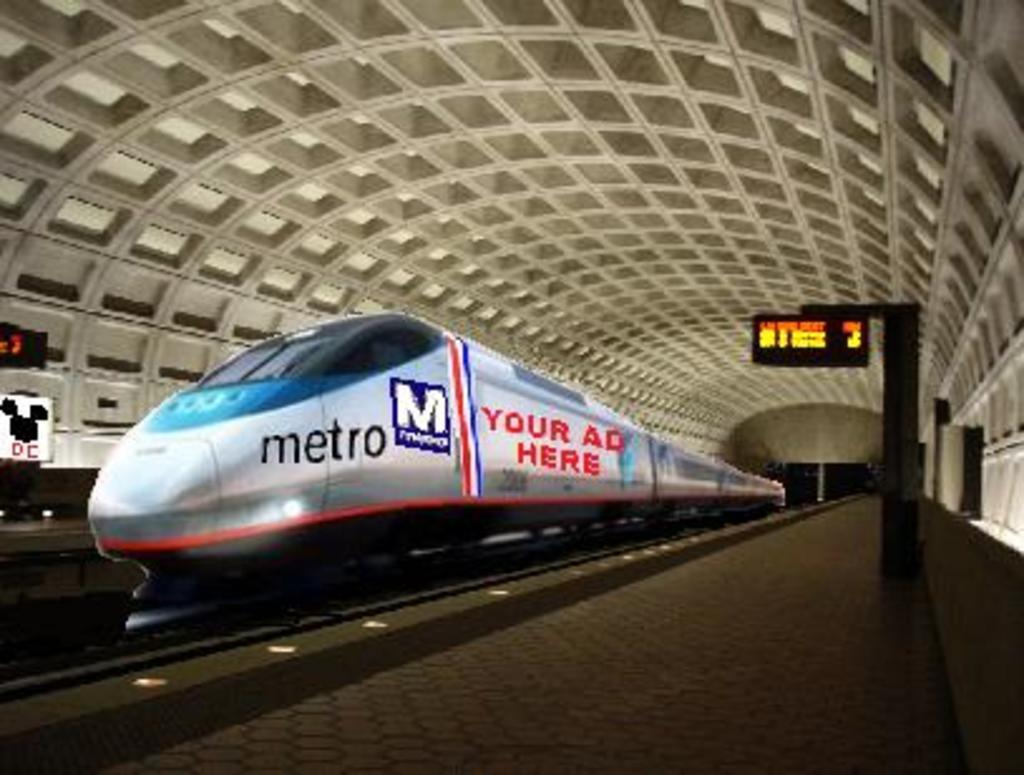Can you describe this image briefly? In the foreground of this edited image, there is a train on a track and on either side there is platform and the boards. At the top, there is inside roof of the shed. 